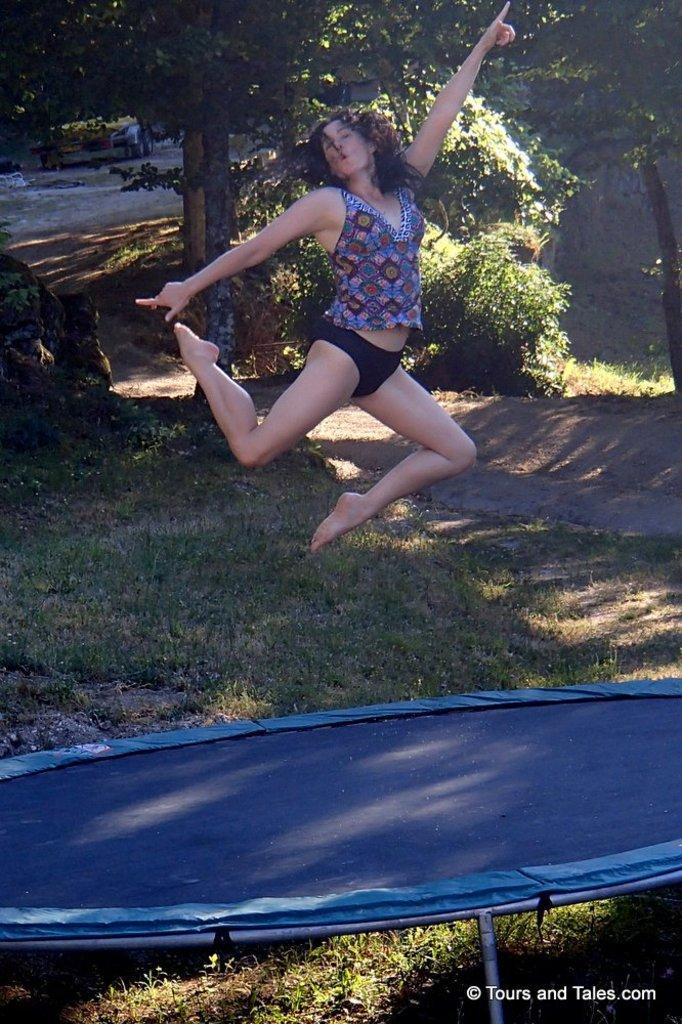Describe this image in one or two sentences. This image consists of a woman jumping on the trampoline. At the bottom, there is blue color trampoline on the green grass. In the background, there are trees. 